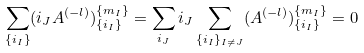<formula> <loc_0><loc_0><loc_500><loc_500>\sum _ { \{ i _ { I } \} } ( i _ { J } A ^ { ( - l ) } ) _ { \{ i _ { I } \} } ^ { \{ m _ { I } \} } = \sum _ { i _ { J } } i _ { J } \sum _ { \{ i _ { I } \} _ { I \not = J } } ( A ^ { ( - l ) } ) _ { \{ i _ { I } \} } ^ { \{ m _ { I } \} } = 0</formula> 